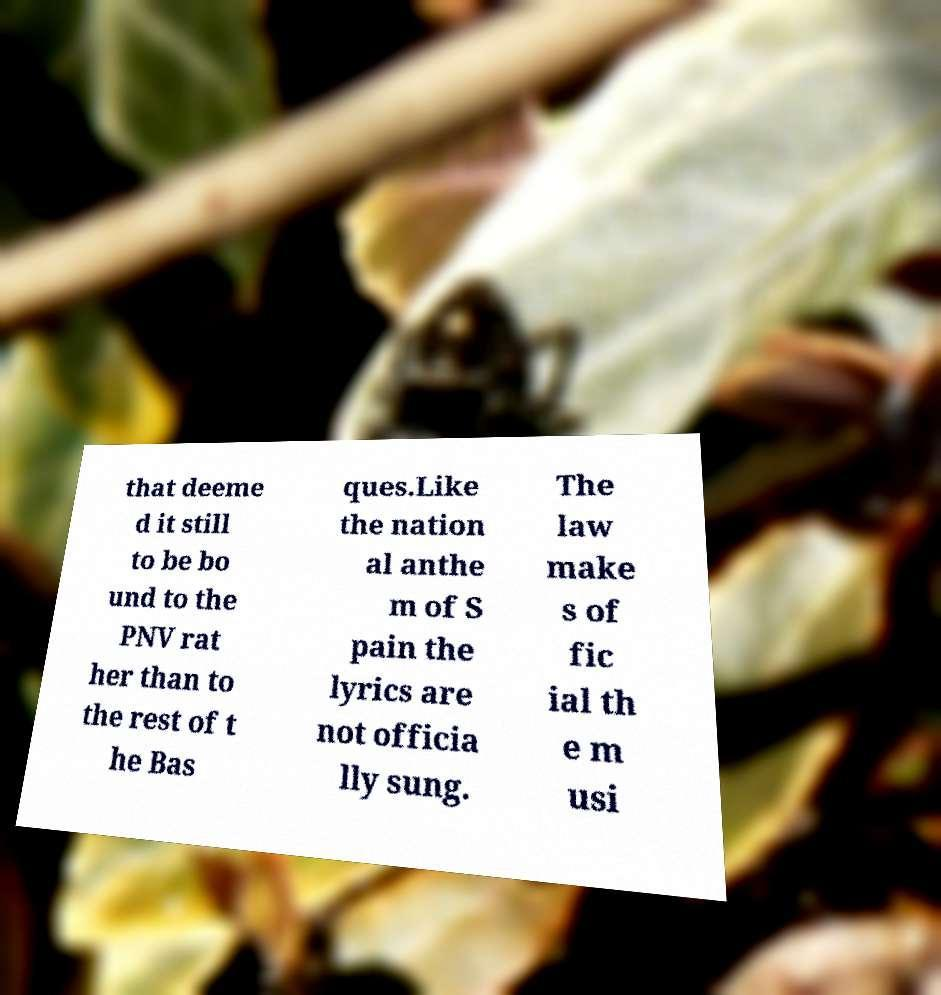Could you extract and type out the text from this image? that deeme d it still to be bo und to the PNV rat her than to the rest of t he Bas ques.Like the nation al anthe m of S pain the lyrics are not officia lly sung. The law make s of fic ial th e m usi 